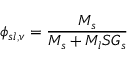Convert formula to latex. <formula><loc_0><loc_0><loc_500><loc_500>\phi _ { s l , v } = { \frac { M _ { s } } { M _ { s } + M _ { l } S G _ { s } } }</formula> 